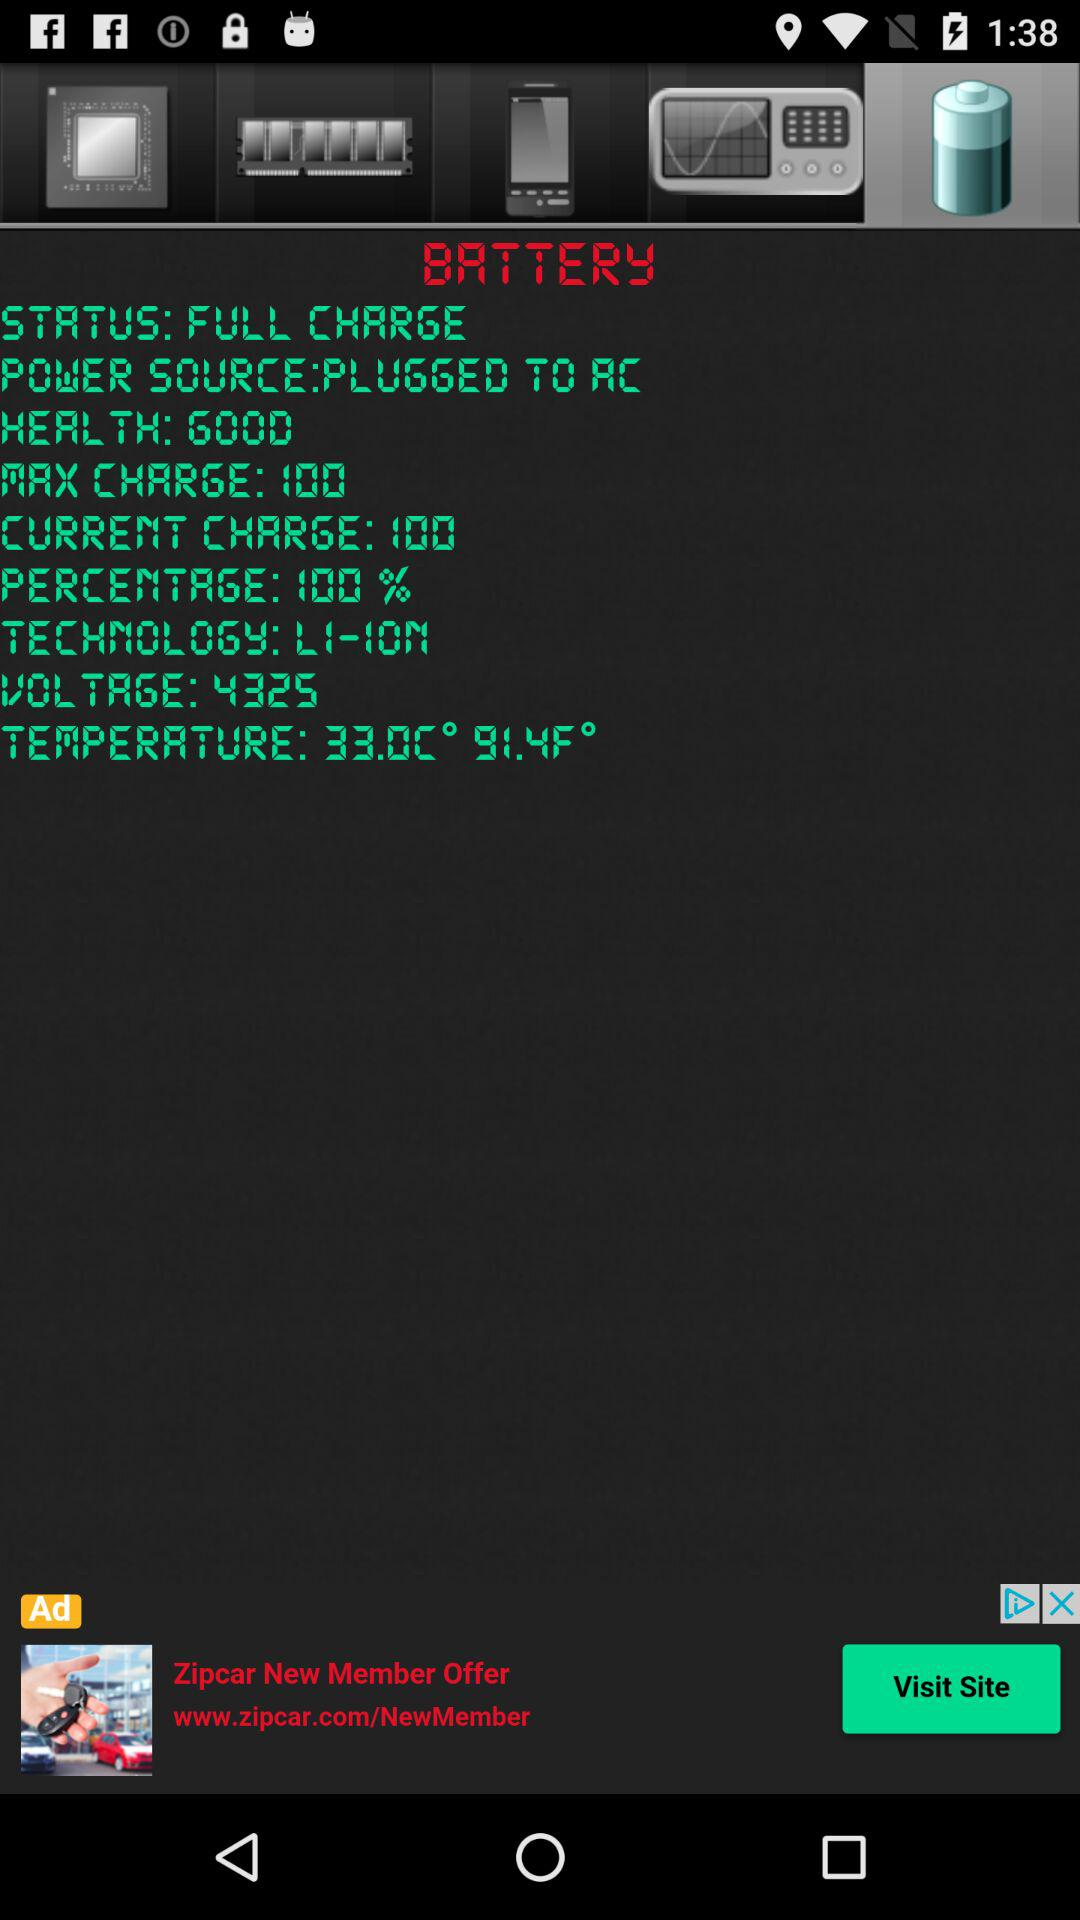What is the status of "BATTERY"? The status is "FULL CHARGE". 